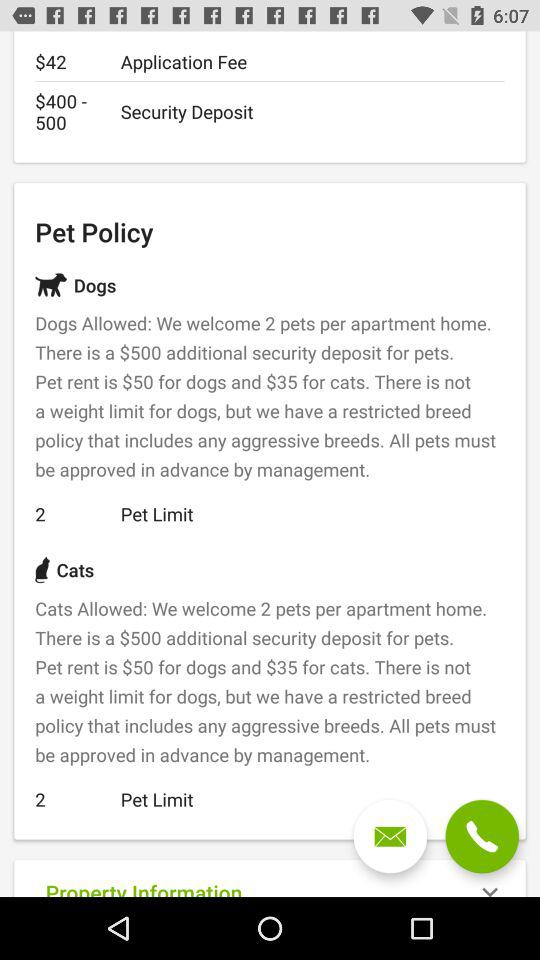How much of the security deposit should be paid? The security deposit ranges from $400 to $500. 